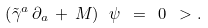<formula> <loc_0><loc_0><loc_500><loc_500>\left ( \tilde { \gamma } ^ { a } \, \partial _ { a } \, + \, M \right ) \ \psi \ = \ 0 \ > .</formula> 